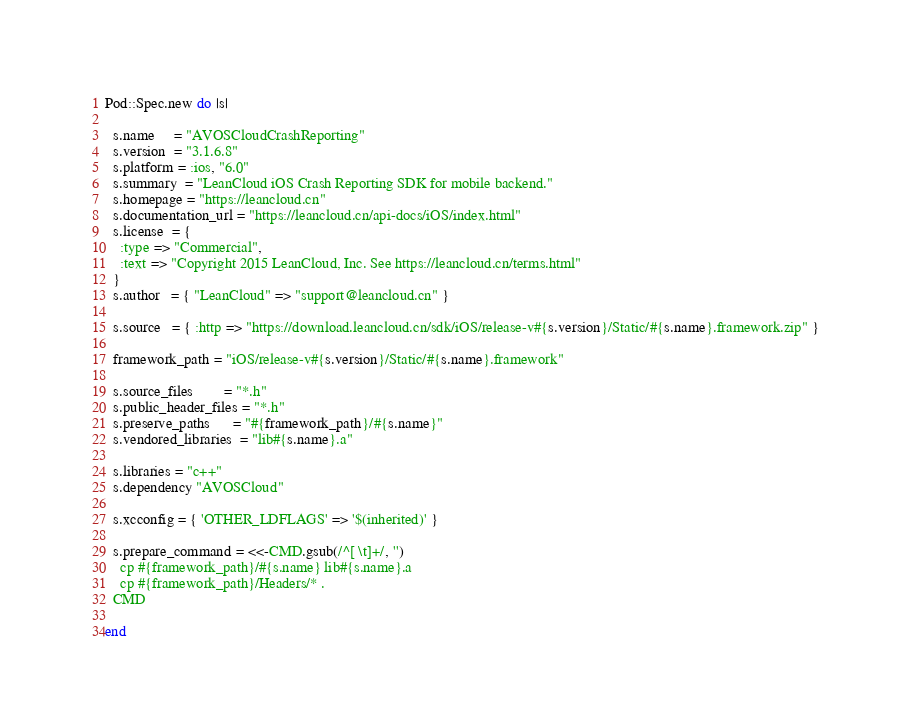Convert code to text. <code><loc_0><loc_0><loc_500><loc_500><_Ruby_>Pod::Spec.new do |s|

  s.name     = "AVOSCloudCrashReporting"
  s.version  = "3.1.6.8"
  s.platform = :ios, "6.0"
  s.summary  = "LeanCloud iOS Crash Reporting SDK for mobile backend."
  s.homepage = "https://leancloud.cn"
  s.documentation_url = "https://leancloud.cn/api-docs/iOS/index.html"
  s.license  = {
    :type => "Commercial",
    :text => "Copyright 2015 LeanCloud, Inc. See https://leancloud.cn/terms.html"
  }
  s.author   = { "LeanCloud" => "support@leancloud.cn" }
  
  s.source   = { :http => "https://download.leancloud.cn/sdk/iOS/release-v#{s.version}/Static/#{s.name}.framework.zip" }

  framework_path = "iOS/release-v#{s.version}/Static/#{s.name}.framework"

  s.source_files        = "*.h"
  s.public_header_files = "*.h"
  s.preserve_paths      = "#{framework_path}/#{s.name}"
  s.vendored_libraries  = "lib#{s.name}.a"

  s.libraries = "c++"
  s.dependency "AVOSCloud"

  s.xcconfig = { 'OTHER_LDFLAGS' => '$(inherited)' }

  s.prepare_command = <<-CMD.gsub(/^[ \t]+/, '')
    cp #{framework_path}/#{s.name} lib#{s.name}.a
    cp #{framework_path}/Headers/* .
  CMD
  
end
</code> 